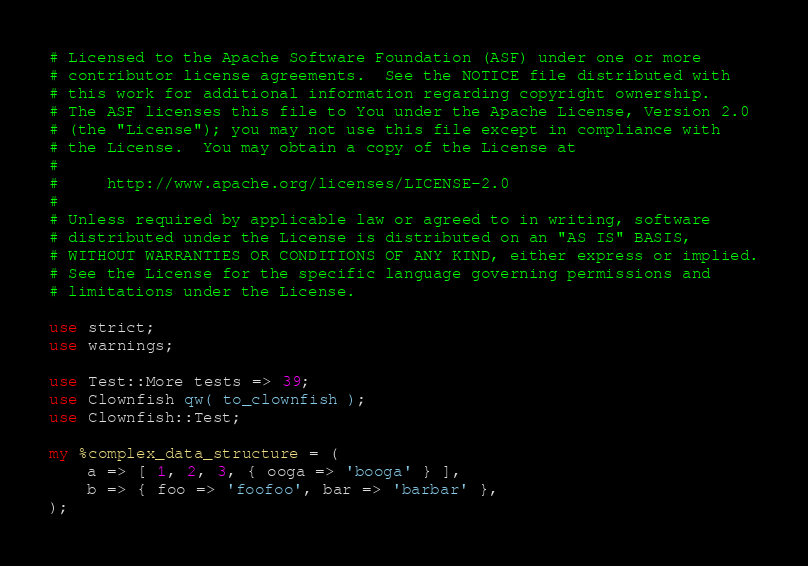<code> <loc_0><loc_0><loc_500><loc_500><_Perl_># Licensed to the Apache Software Foundation (ASF) under one or more
# contributor license agreements.  See the NOTICE file distributed with
# this work for additional information regarding copyright ownership.
# The ASF licenses this file to You under the Apache License, Version 2.0
# (the "License"); you may not use this file except in compliance with
# the License.  You may obtain a copy of the License at
#
#     http://www.apache.org/licenses/LICENSE-2.0
#
# Unless required by applicable law or agreed to in writing, software
# distributed under the License is distributed on an "AS IS" BASIS,
# WITHOUT WARRANTIES OR CONDITIONS OF ANY KIND, either express or implied.
# See the License for the specific language governing permissions and
# limitations under the License.

use strict;
use warnings;

use Test::More tests => 39;
use Clownfish qw( to_clownfish );
use Clownfish::Test;

my %complex_data_structure = (
    a => [ 1, 2, 3, { ooga => 'booga' } ],
    b => { foo => 'foofoo', bar => 'barbar' },
);</code> 